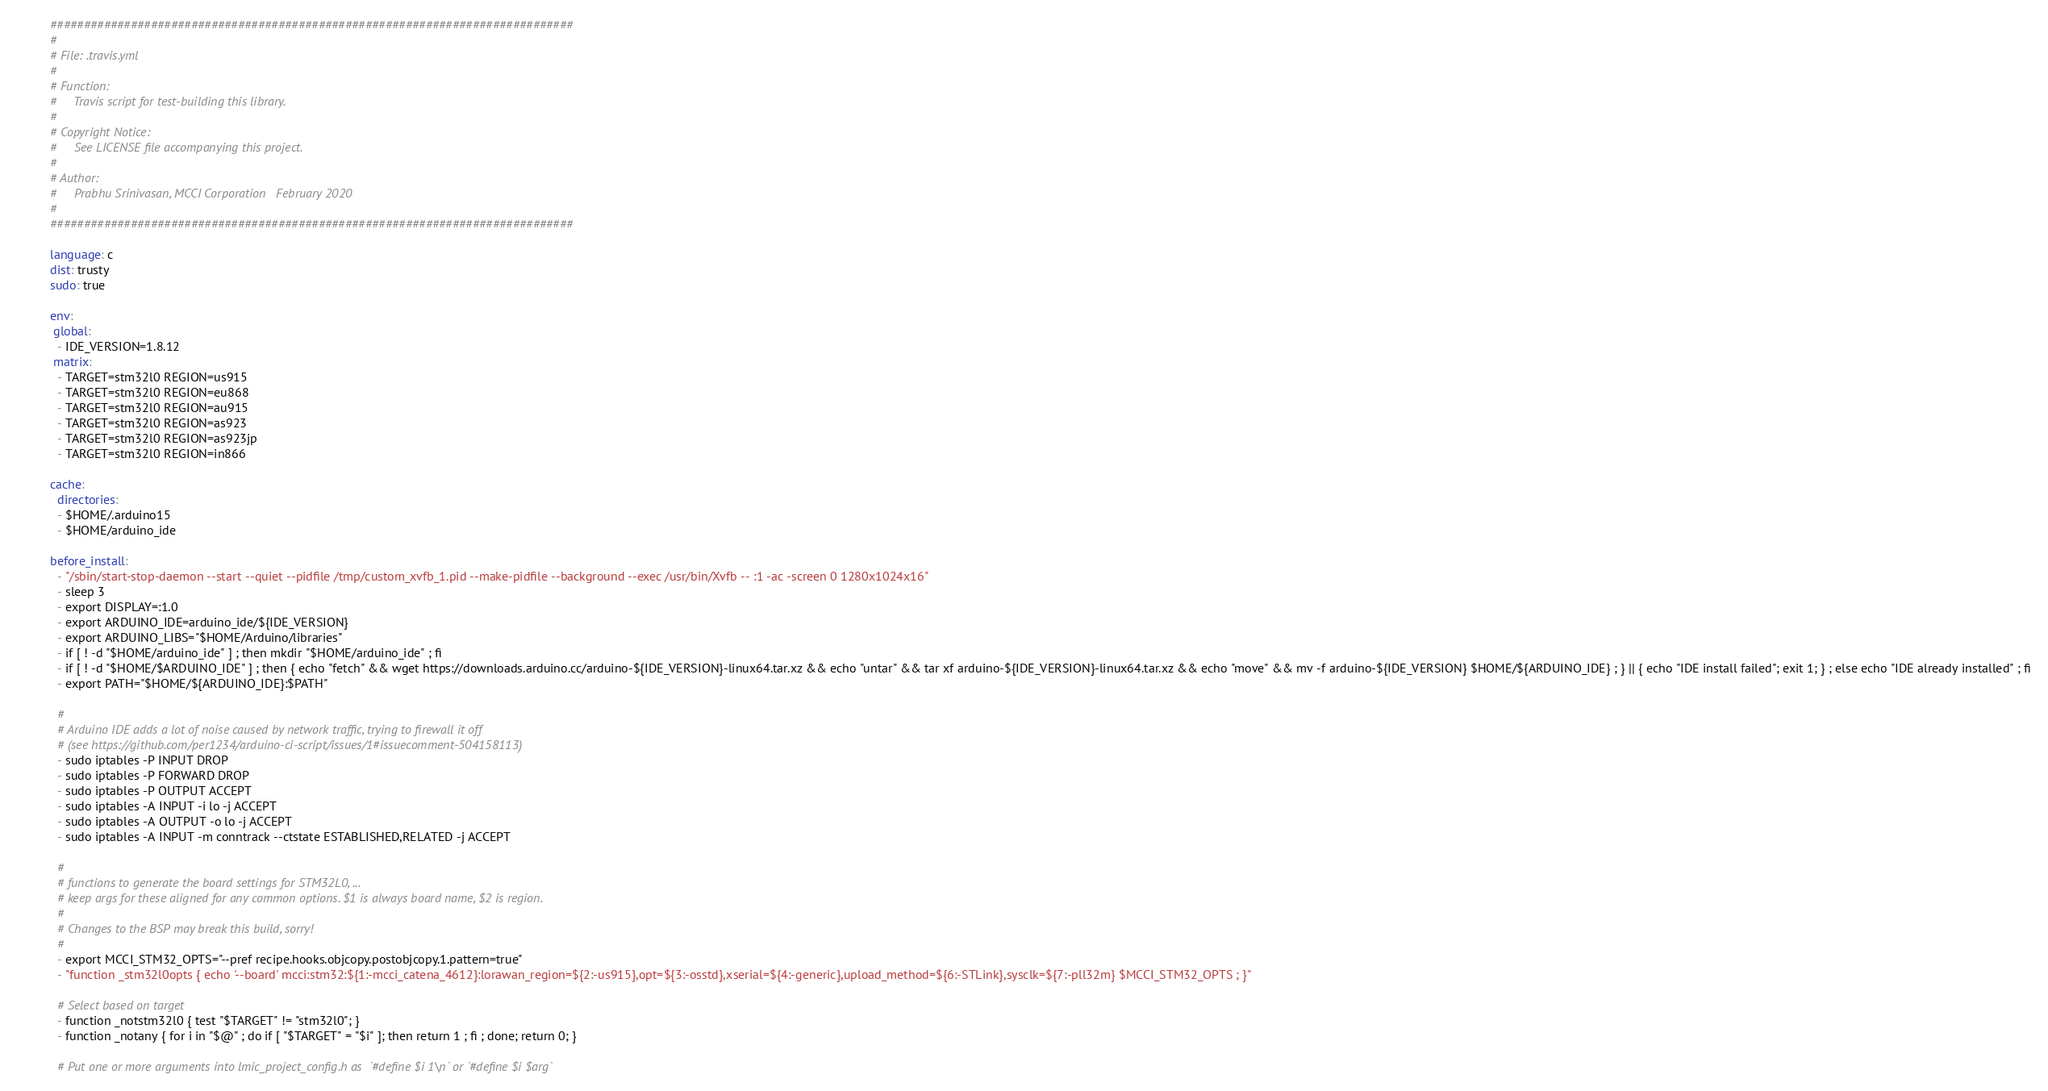Convert code to text. <code><loc_0><loc_0><loc_500><loc_500><_YAML_>##############################################################################
#
# File: .travis.yml
#
# Function:
#     Travis script for test-building this library.
#
# Copyright Notice:
#     See LICENSE file accompanying this project.
#
# Author:
#     Prabhu Srinivasan, MCCI Corporation   February 2020
# 
##############################################################################

language: c
dist: trusty
sudo: true

env:
 global:
  - IDE_VERSION=1.8.12
 matrix:
  - TARGET=stm32l0 REGION=us915
  - TARGET=stm32l0 REGION=eu868
  - TARGET=stm32l0 REGION=au915
  - TARGET=stm32l0 REGION=as923
  - TARGET=stm32l0 REGION=as923jp
  - TARGET=stm32l0 REGION=in866

cache:
  directories:
  - $HOME/.arduino15
  - $HOME/arduino_ide

before_install:
  - "/sbin/start-stop-daemon --start --quiet --pidfile /tmp/custom_xvfb_1.pid --make-pidfile --background --exec /usr/bin/Xvfb -- :1 -ac -screen 0 1280x1024x16"
  - sleep 3
  - export DISPLAY=:1.0
  - export ARDUINO_IDE=arduino_ide/${IDE_VERSION}
  - export ARDUINO_LIBS="$HOME/Arduino/libraries"
  - if [ ! -d "$HOME/arduino_ide" ] ; then mkdir "$HOME/arduino_ide" ; fi
  - if [ ! -d "$HOME/$ARDUINO_IDE" ] ; then { echo "fetch" && wget https://downloads.arduino.cc/arduino-${IDE_VERSION}-linux64.tar.xz && echo "untar" && tar xf arduino-${IDE_VERSION}-linux64.tar.xz && echo "move" && mv -f arduino-${IDE_VERSION} $HOME/${ARDUINO_IDE} ; } || { echo "IDE install failed"; exit 1; } ; else echo "IDE already installed" ; fi
  - export PATH="$HOME/${ARDUINO_IDE}:$PATH"

  #
  # Arduino IDE adds a lot of noise caused by network traffic, trying to firewall it off
  # (see https://github.com/per1234/arduino-ci-script/issues/1#issuecomment-504158113)
  - sudo iptables -P INPUT DROP
  - sudo iptables -P FORWARD DROP
  - sudo iptables -P OUTPUT ACCEPT
  - sudo iptables -A INPUT -i lo -j ACCEPT
  - sudo iptables -A OUTPUT -o lo -j ACCEPT
  - sudo iptables -A INPUT -m conntrack --ctstate ESTABLISHED,RELATED -j ACCEPT

  #
  # functions to generate the board settings for STM32L0, ...
  # keep args for these aligned for any common options. $1 is always board name, $2 is region.
  #
  # Changes to the BSP may break this build, sorry!
  #
  - export MCCI_STM32_OPTS="--pref recipe.hooks.objcopy.postobjcopy.1.pattern=true"
  - "function _stm32l0opts { echo '--board' mcci:stm32:${1:-mcci_catena_4612}:lorawan_region=${2:-us915},opt=${3:-osstd},xserial=${4:-generic},upload_method=${6:-STLink},sysclk=${7:-pll32m} $MCCI_STM32_OPTS ; }"
  
  # Select based on target
  - function _notstm32l0 { test "$TARGET" != "stm32l0"; }
  - function _notany { for i in "$@" ; do if [ "$TARGET" = "$i" ]; then return 1 ; fi ; done; return 0; }

  # Put one or more arguments into lmic_project_config.h as  `#define $i 1\n` or `#define $i $arg`</code> 